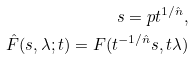<formula> <loc_0><loc_0><loc_500><loc_500>s = p t ^ { 1 / { \hat { n } } } , \\ { \hat { F } } ( s , \lambda ; t ) = { F } ( t ^ { - 1 / { \hat { n } } } s , t \lambda )</formula> 